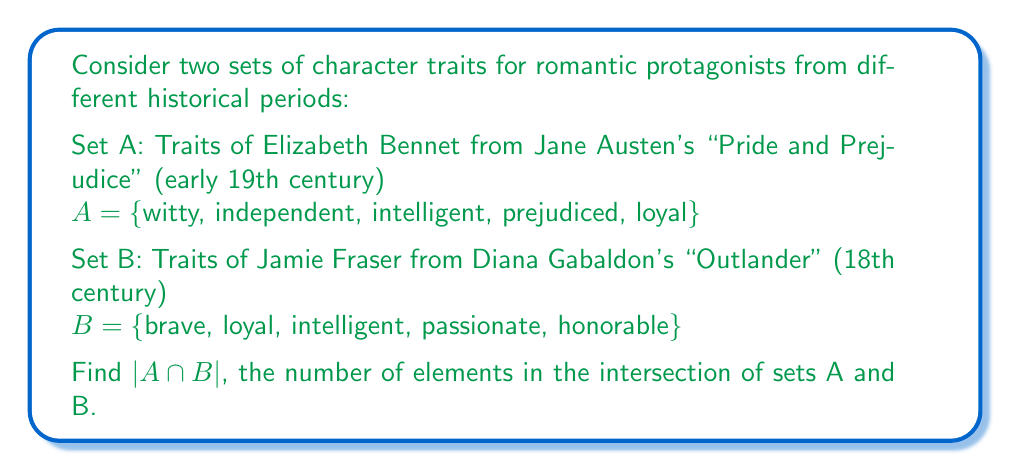What is the answer to this math problem? To solve this problem, we need to follow these steps:

1. Identify the elements that are common to both sets A and B.
2. Count the number of common elements.

Let's examine each trait:

1. Witty: Only in set A
2. Independent: Only in set A
3. Intelligent: In both sets A and B
4. Prejudiced: Only in set A
5. Loyal: In both sets A and B
6. Brave: Only in set B
7. Passionate: Only in set B
8. Honorable: Only in set B

We can see that "intelligent" and "loyal" are the only traits that appear in both sets.

Therefore, the intersection of sets A and B is:

$A \cap B = \text{\{intelligent, loyal\}}$

To find $|A \cap B|$, we simply count the number of elements in this intersection.

$|A \cap B| = 2$

This result shows that despite being from different historical periods, Elizabeth Bennet and Jamie Fraser share two character traits: intelligence and loyalty.
Answer: $|A \cap B| = 2$ 